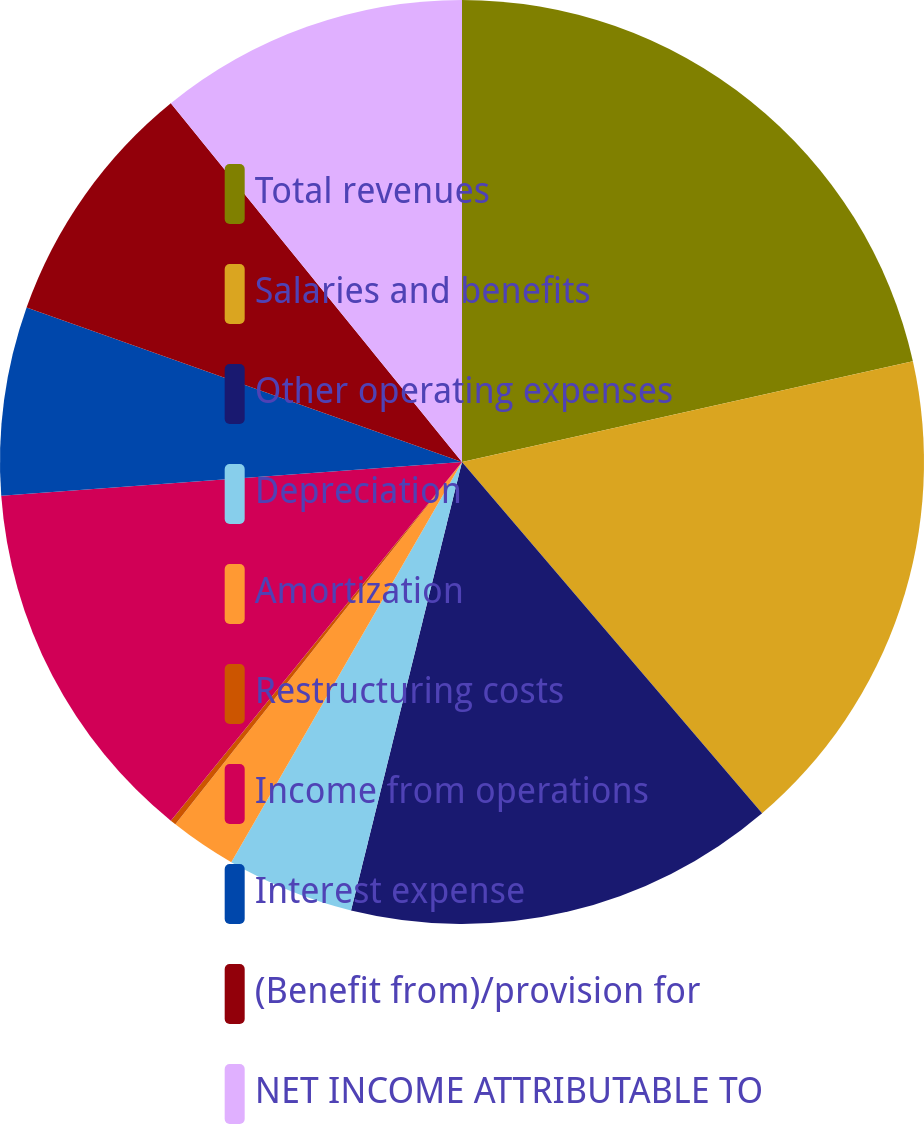<chart> <loc_0><loc_0><loc_500><loc_500><pie_chart><fcel>Total revenues<fcel>Salaries and benefits<fcel>Other operating expenses<fcel>Depreciation<fcel>Amortization<fcel>Restructuring costs<fcel>Income from operations<fcel>Interest expense<fcel>(Benefit from)/provision for<fcel>NET INCOME ATTRIBUTABLE TO<nl><fcel>21.5%<fcel>17.24%<fcel>15.11%<fcel>4.46%<fcel>2.33%<fcel>0.2%<fcel>12.98%<fcel>6.59%<fcel>8.72%<fcel>10.85%<nl></chart> 